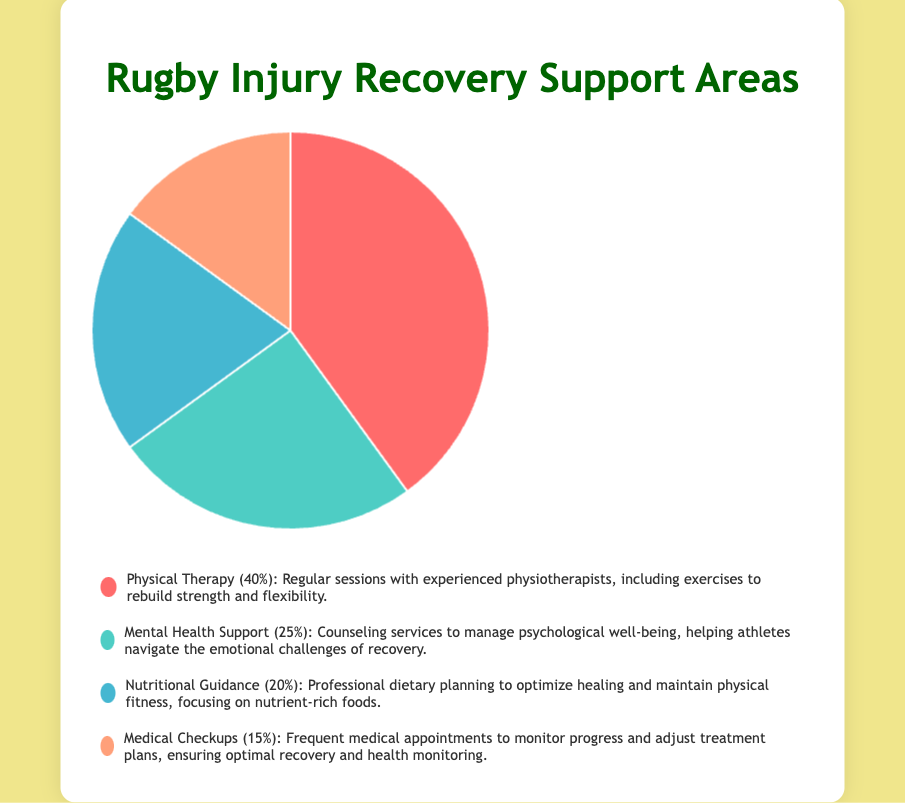What percentage of the support areas focuses on medical aspects, such as physical therapy and medical checkups combined? To find the total percentage focused on medical aspects, you need to add the percentages of Physical Therapy and Medical Checkups. The pie chart shows 40% for Physical Therapy and 15% for Medical Checkups. So, 40% + 15% = 55%.
Answer: 55% Which support area needs the least attention according to the pie chart? Look at the support areas and their corresponding percentages. Medical Checkups have the smallest percentage at 15%.
Answer: Medical Checkups Compare the need for physical therapy to the need for mental health support. Which one is greater, and by how much? Physical Therapy has a percentage of 40%, while Mental Health Support has 25%. The difference is 40% - 25% = 15%.
Answer: Physical Therapy by 15% Sum the percentages of Nutritional Guidance and Mental Health Support. What is their combined total? Nutritional Guidance needs 20% and Mental Health Support needs 25%. Their combined total is 20% + 25% = 45%.
Answer: 45% Which areas of support combined constitute exactly half of the pie chart? First, check each pair's total until you find one that sums to 50%. Physical Therapy (40%) and Nutritional Guidance (20%) sum to 60%, while Physical Therapy (40%) and Medical Checkups (15%) sum to 55%. Mental Health Support (25%) and Nutritional Guidance (20%) sum to 45%. However, the pair Mental Health Support (25%) and Medical Checkups (15%) sum exactly to 40%.
Answer: No pair What is the second most emphasized area of support shown in the pie chart? The pie chart highlights the areas with their percentages. The second highest percentage after Physical Therapy (40%) is Mental Health Support (25%).
Answer: Mental Health Support If you combine the areas that focus on non-physical aspects, such as mental health and nutritional guidance, what percentage of the pie chart do they make up? This would be the sum of Mental Health Support (25%) and Nutritional Guidance (20%). So, the combined percentage is 25% + 20% = 45%.
Answer: 45% Describe the color representation of the largest area of support needed. The largest area is Physical Therapy, which has a percentage of 40%. According to the color legend, Physical Therapy is represented by the color red.
Answer: Red Among the non-medical aspects of recovery (mental health and nutritional guidance), which one is represented by a cooler color tone in the pie chart? The pie chart uses blue tones for certain sections. Nutritional Guidance has a percentage of 20% and appears in blue, while Mental Health Support (25%) is in a greenish tone (teal). The cooler color tone is used for Nutritional Guidance.
Answer: Nutritional Guidance 